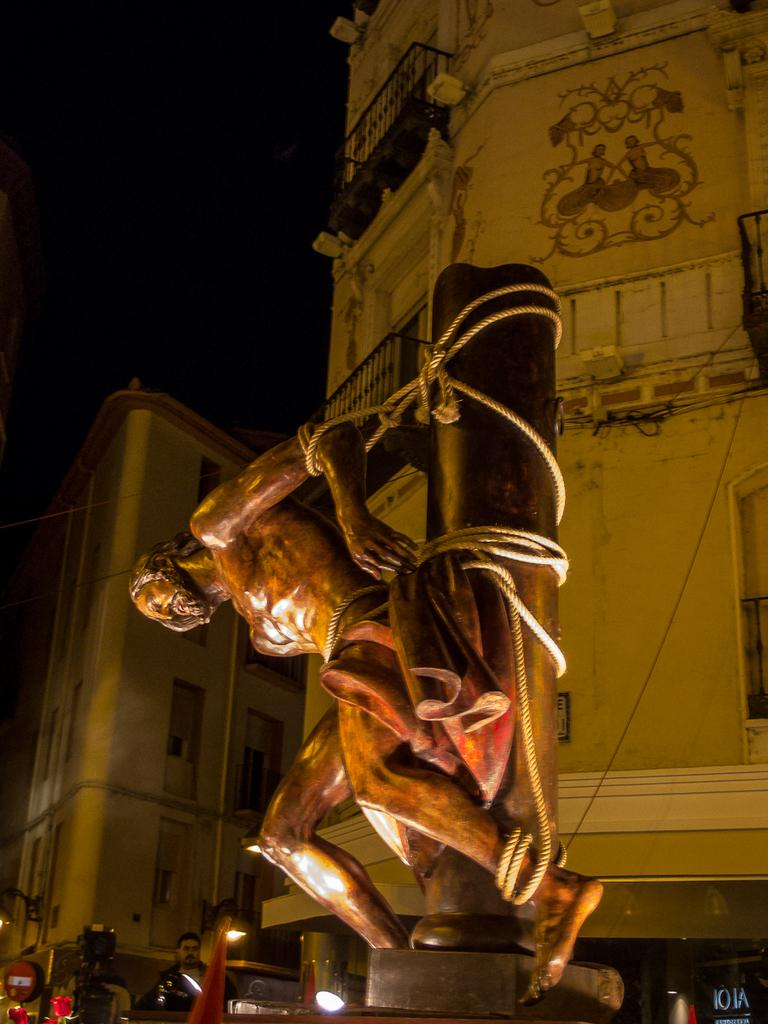What is the main subject of the image? There is a human statue in the image. How is the statue secured in the image? The statue is tied with a rope to a wooden pole. Can you describe the person in the image? There is a person standing on the ground in the image. What can be seen in the distance in the image? There are buildings visible in the background of the image. How would you describe the lighting in the image? The sky appears to be dark in the image. Is the statue sinking in quicksand in the image? No, there is no quicksand present in the image. The statue is tied to a wooden pole, and the ground appears to be solid. 